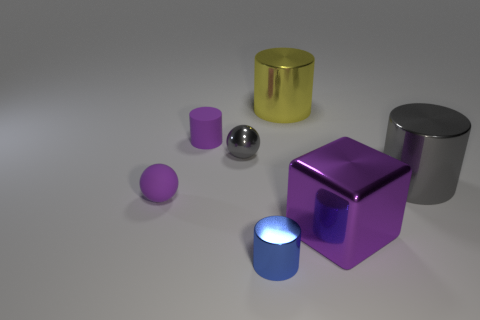There is a large object that is the same color as the tiny metal sphere; what shape is it?
Your answer should be compact. Cylinder. There is a small matte sphere; is its color the same as the cylinder left of the tiny blue thing?
Your answer should be compact. Yes. Is there a object of the same color as the small shiny ball?
Your answer should be very brief. Yes. What size is the metal thing that is the same color as the metallic sphere?
Your answer should be very brief. Large. Does the block have the same color as the rubber cylinder?
Provide a short and direct response. Yes. There is a object right of the big purple shiny block; is its color the same as the shiny ball?
Keep it short and to the point. Yes. There is a small blue cylinder; what number of tiny gray metallic things are behind it?
Give a very brief answer. 1. Is the number of blue metallic cylinders greater than the number of big blue shiny objects?
Offer a very short reply. Yes. What is the shape of the large object that is in front of the yellow object and to the left of the big gray thing?
Provide a short and direct response. Cube. Is there a tiny cyan sphere?
Offer a very short reply. No. 